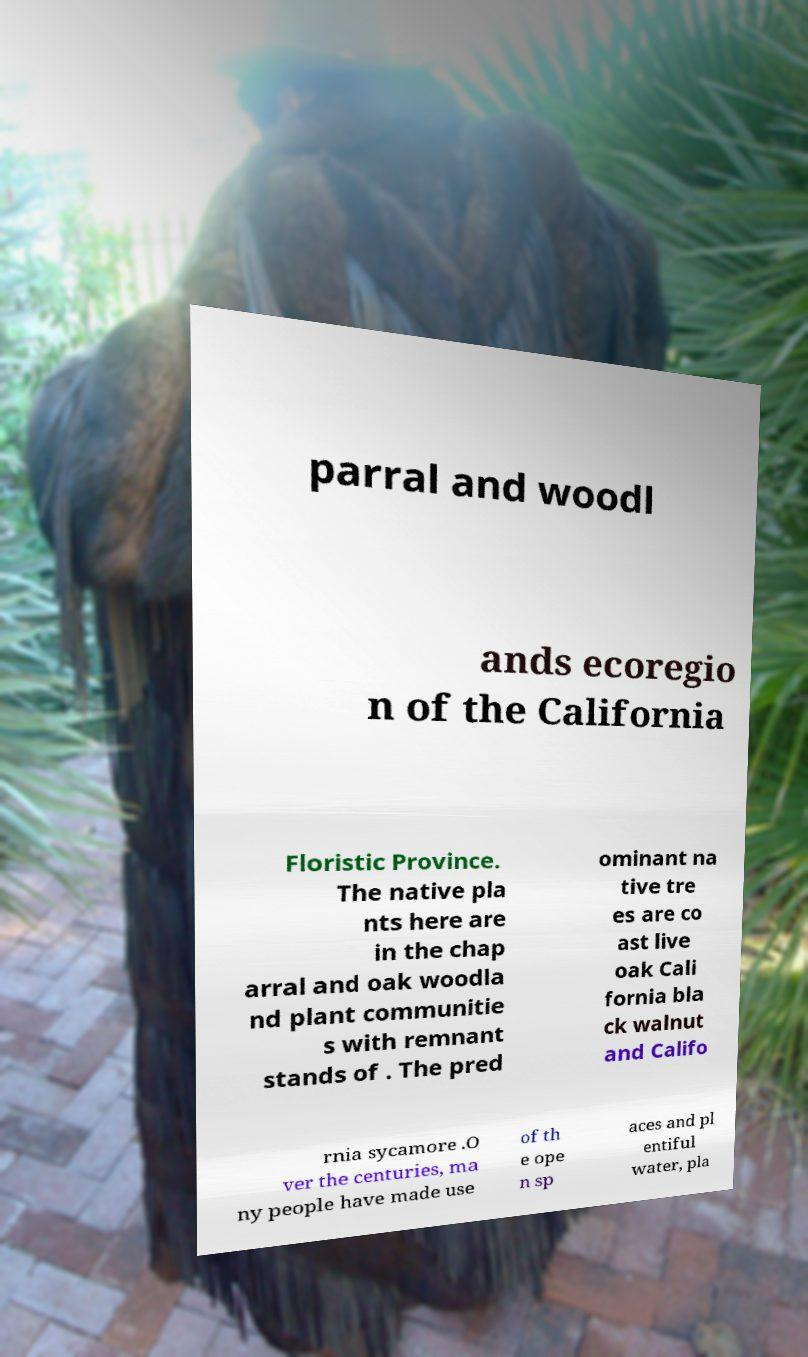Please read and relay the text visible in this image. What does it say? parral and woodl ands ecoregio n of the California Floristic Province. The native pla nts here are in the chap arral and oak woodla nd plant communitie s with remnant stands of . The pred ominant na tive tre es are co ast live oak Cali fornia bla ck walnut and Califo rnia sycamore .O ver the centuries, ma ny people have made use of th e ope n sp aces and pl entiful water, pla 